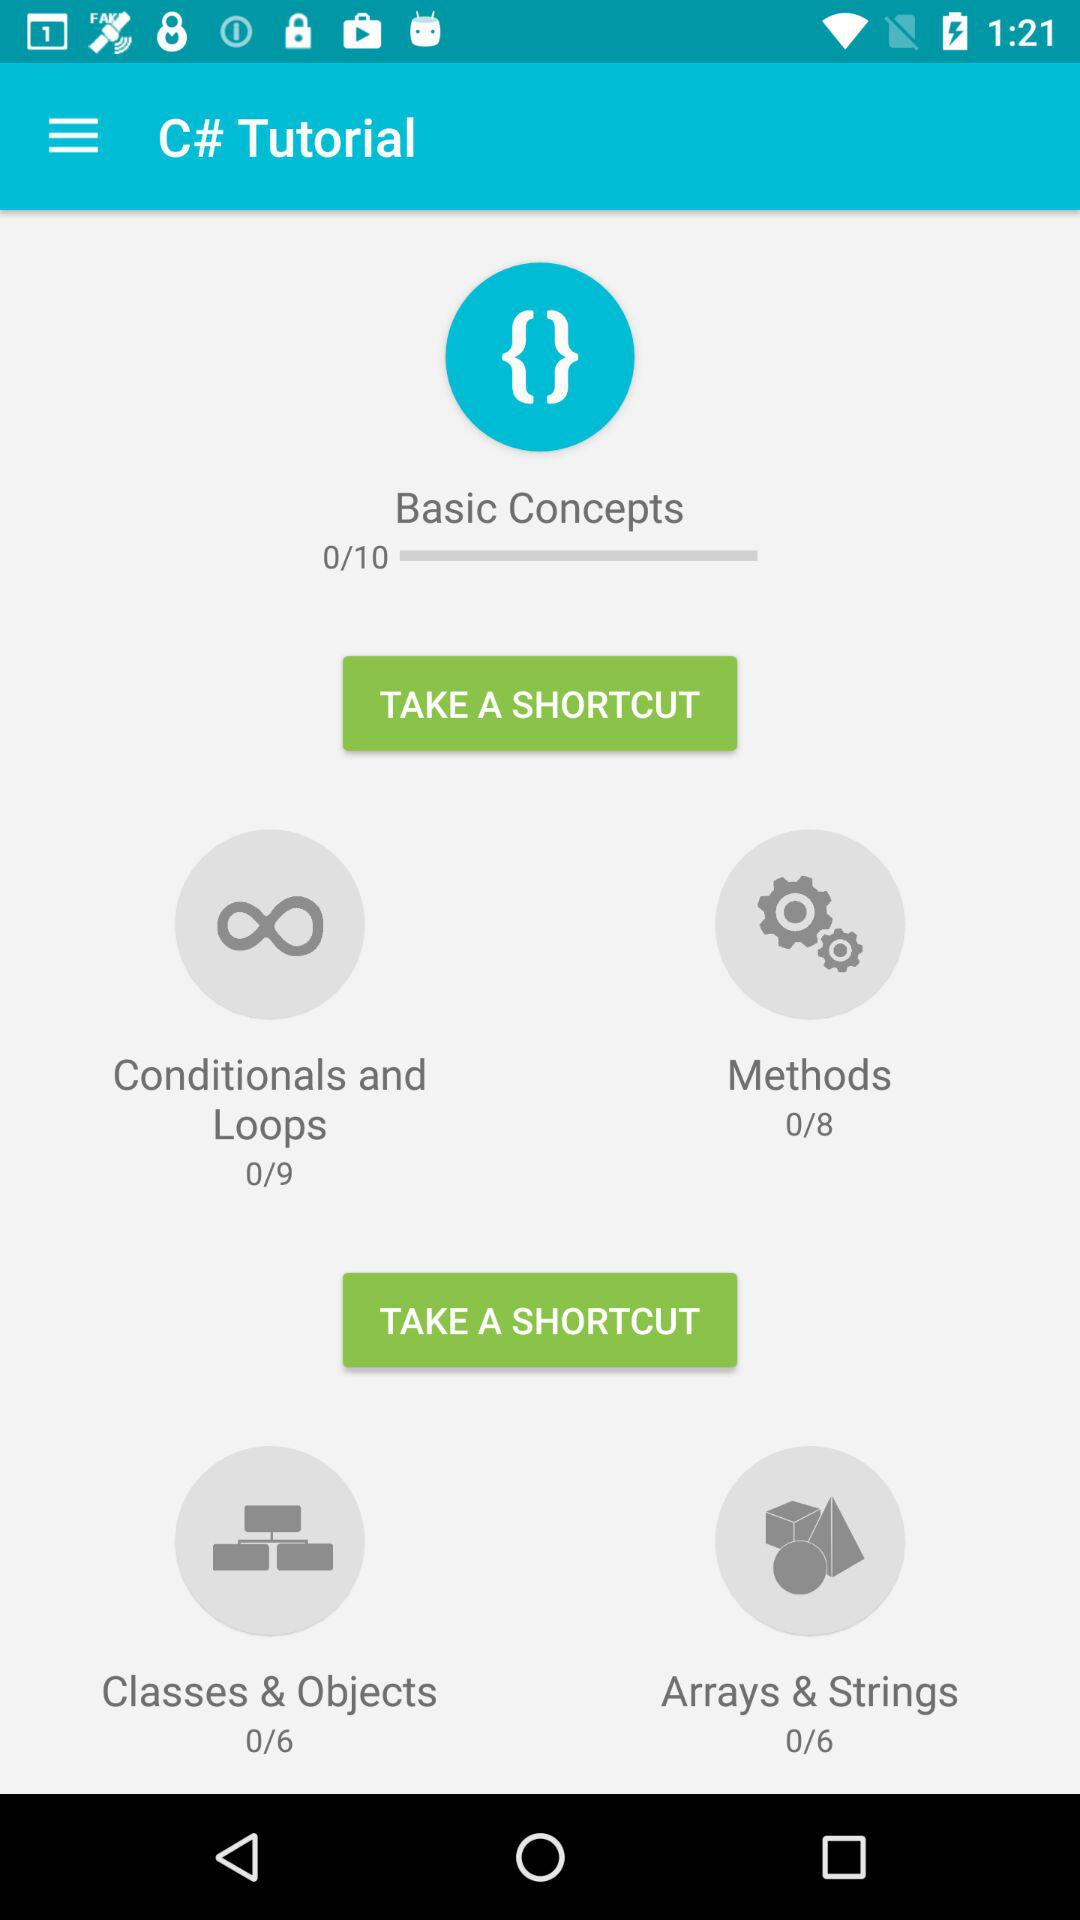How many methods in total are given? There are 8 methods in total. 